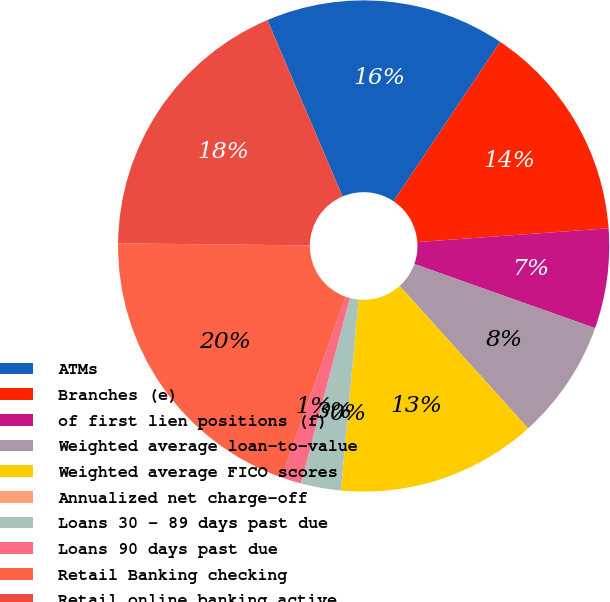<chart> <loc_0><loc_0><loc_500><loc_500><pie_chart><fcel>ATMs<fcel>Branches (e)<fcel>of first lien positions (f)<fcel>Weighted average loan-to-value<fcel>Weighted average FICO scores<fcel>Annualized net charge-off<fcel>Loans 30 - 89 days past due<fcel>Loans 90 days past due<fcel>Retail Banking checking<fcel>Retail online banking active<nl><fcel>15.79%<fcel>14.47%<fcel>6.58%<fcel>7.89%<fcel>13.16%<fcel>0.0%<fcel>2.63%<fcel>1.32%<fcel>19.74%<fcel>18.42%<nl></chart> 